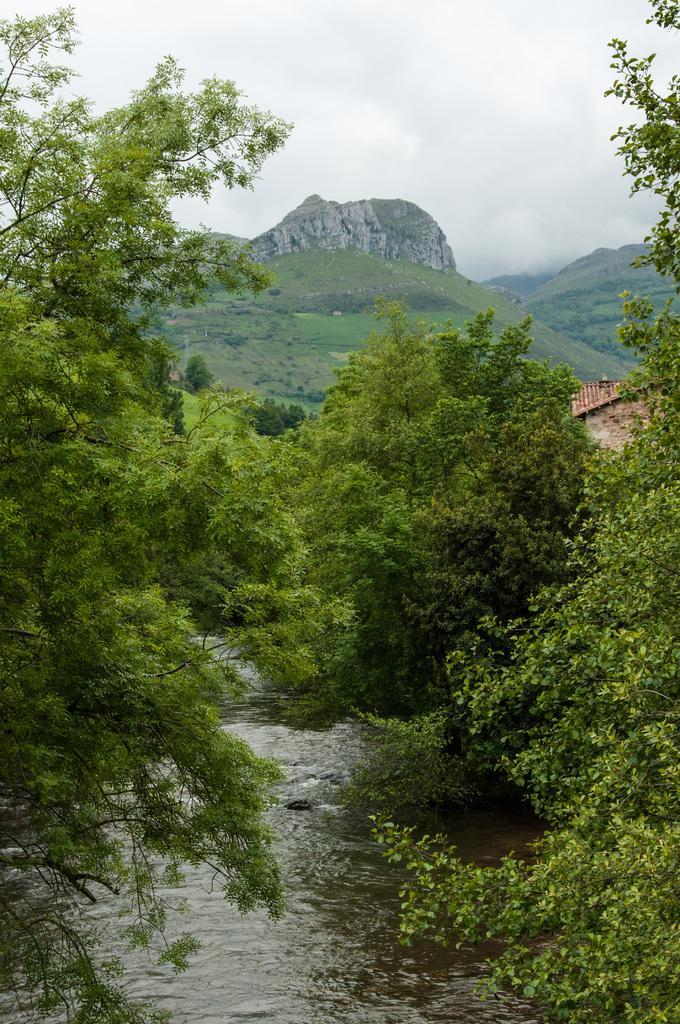How would you summarize this image in a sentence or two? In this image I can see water, background I can see trees and grass in green color, mountains, and the sky is in white color. 